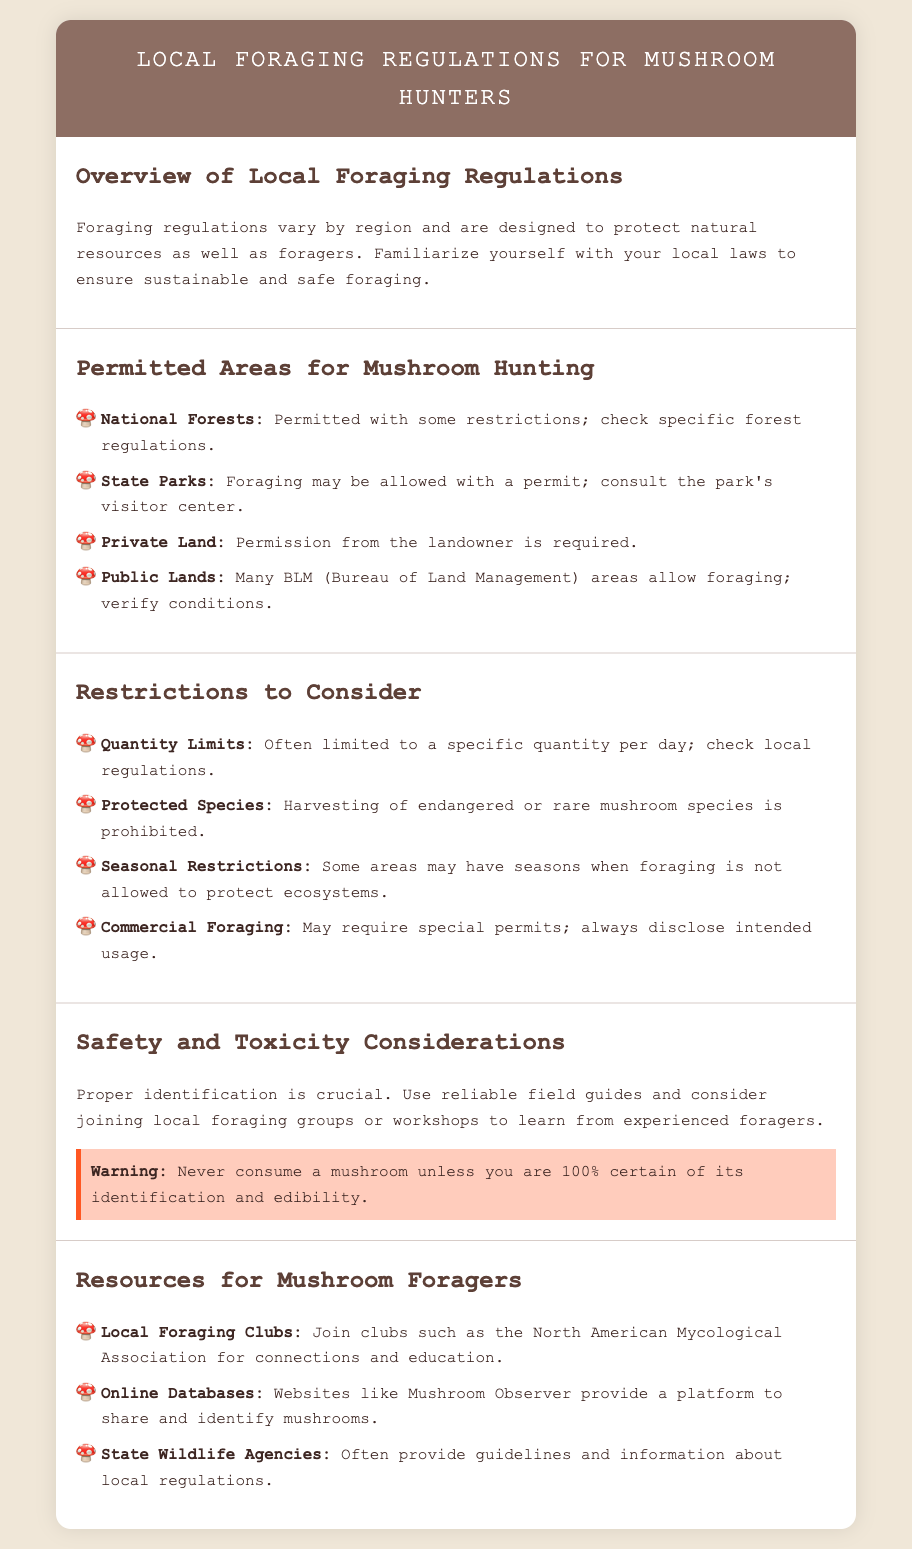What are National Forests? National Forests are areas where mushroom hunting is permitted with some restrictions; it's important to check specific forest regulations.
Answer: Permitted with some restrictions What is required for foraging on private land? To forage on private land, you need permission from the landowner.
Answer: Permission from the landowner What should you check regarding quantity limits? You should verify local regulations to learn about specific quantity limits for mushroom foraging.
Answer: Local regulations What species cannot be harvested? You cannot harvest endangered or rare mushroom species.
Answer: Endangered or rare species Why is proper identification crucial? Proper identification is crucial to avoid toxicity; unreliably identified mushrooms can be harmful or deadly.
Answer: Avoid toxicity What kind of permits may be required for commercial foraging? Commercial foraging may require special permits that must be disclosed based on intended usage.
Answer: Special permits What are two resources for mushroom foragers? Local Foraging Clubs and Online Databases are great resources for connecting with others and identifying mushrooms.
Answer: Local Foraging Clubs, Online Databases What does the warning advise about mushroom consumption? The warning advises that you should never consume a mushroom unless you are 100% certain of its identification and edibility.
Answer: 100% certain of its identification and edibility 